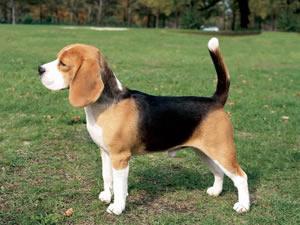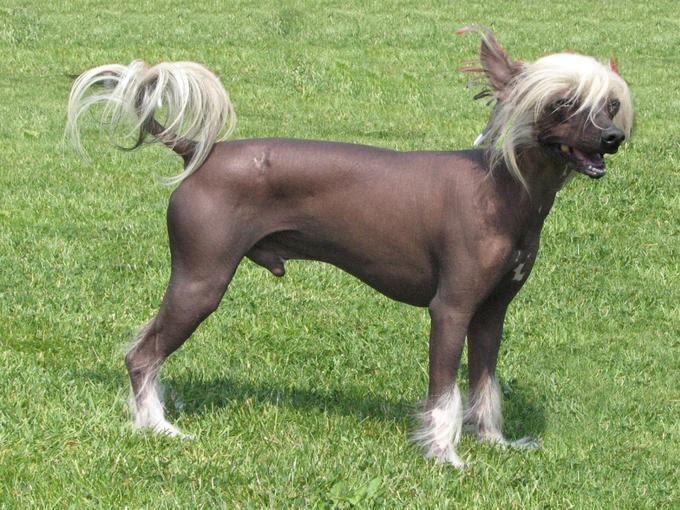The first image is the image on the left, the second image is the image on the right. Given the left and right images, does the statement "The dog in the image on the left is wearing a leash." hold true? Answer yes or no. No. 